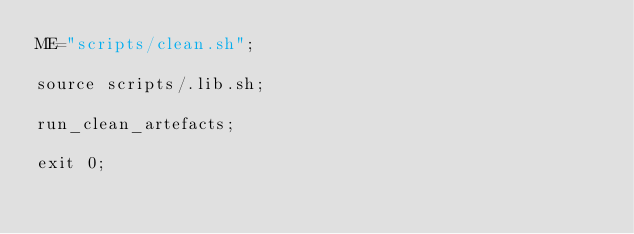Convert code to text. <code><loc_0><loc_0><loc_500><loc_500><_Bash_>ME="scripts/clean.sh";

source scripts/.lib.sh;

run_clean_artefacts;

exit 0;
</code> 